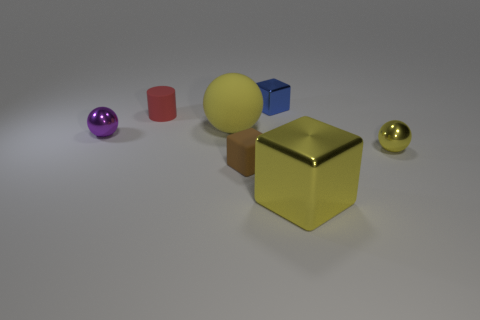The metal object on the left side of the small blue object is what color?
Provide a succinct answer. Purple. Are there any things in front of the tiny metal thing on the left side of the brown block?
Keep it short and to the point. Yes. There is a rubber ball; is its color the same as the small rubber thing that is behind the small purple metal thing?
Give a very brief answer. No. Are there any other tiny purple things made of the same material as the purple object?
Provide a succinct answer. No. How many cubes are there?
Your answer should be compact. 3. What material is the large thing on the right side of the large yellow object that is to the left of the large metallic cube?
Your answer should be compact. Metal. There is a small block that is made of the same material as the big sphere; what color is it?
Make the answer very short. Brown. There is a tiny metallic object that is the same color as the matte ball; what is its shape?
Offer a terse response. Sphere. There is a metal thing right of the yellow shiny cube; does it have the same size as the brown object that is on the left side of the big shiny block?
Provide a succinct answer. Yes. What number of balls are either small brown rubber objects or blue things?
Ensure brevity in your answer.  0. 